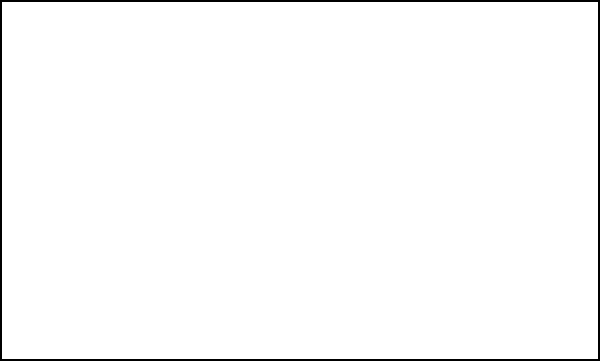You're arranging a new display case for your café. The case has two shelves, and you want to organize 8 different pastries (labeled A to H) to maximize visual appeal. If you decide to put all circular pastries on the bottom shelf and all rectangular pastries on the top shelf, how many pastries will be on each shelf? To solve this spatial reasoning task, let's follow these steps:

1. Identify the shapes of the pastries:
   - Circular pastries: A, B, C, D, E
   - Rectangular pastries: F, G, H

2. Count the number of pastries for each shape:
   - Number of circular pastries = 5
   - Number of rectangular pastries = 3

3. Assign the pastries to shelves based on the given condition:
   - Bottom shelf (circular pastries): A, B, C, D, E
   - Top shelf (rectangular pastries): F, G, H

4. Count the number of pastries on each shelf:
   - Bottom shelf: 5 pastries
   - Top shelf: 3 pastries

Therefore, if you arrange the pastries according to their shape, there will be 5 pastries on the bottom shelf and 3 pastries on the top shelf.
Answer: Bottom shelf: 5, Top shelf: 3 